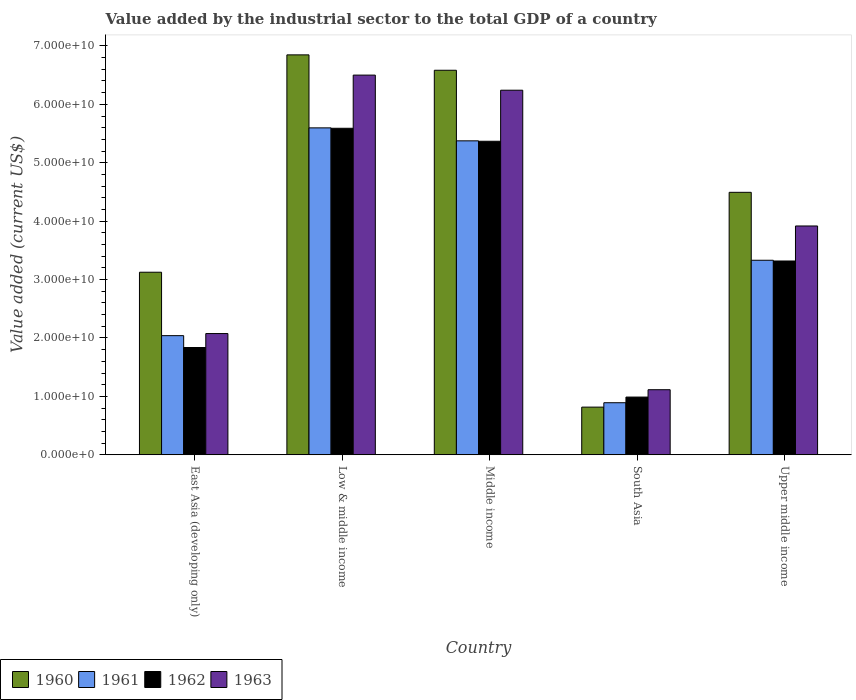Are the number of bars on each tick of the X-axis equal?
Provide a short and direct response. Yes. How many bars are there on the 1st tick from the left?
Your response must be concise. 4. How many bars are there on the 2nd tick from the right?
Give a very brief answer. 4. What is the label of the 1st group of bars from the left?
Keep it short and to the point. East Asia (developing only). What is the value added by the industrial sector to the total GDP in 1960 in South Asia?
Provide a short and direct response. 8.16e+09. Across all countries, what is the maximum value added by the industrial sector to the total GDP in 1963?
Keep it short and to the point. 6.50e+1. Across all countries, what is the minimum value added by the industrial sector to the total GDP in 1963?
Offer a terse response. 1.11e+1. What is the total value added by the industrial sector to the total GDP in 1963 in the graph?
Your answer should be very brief. 1.98e+11. What is the difference between the value added by the industrial sector to the total GDP in 1961 in Low & middle income and that in Middle income?
Make the answer very short. 2.22e+09. What is the difference between the value added by the industrial sector to the total GDP in 1962 in East Asia (developing only) and the value added by the industrial sector to the total GDP in 1961 in Middle income?
Keep it short and to the point. -3.54e+1. What is the average value added by the industrial sector to the total GDP in 1960 per country?
Your response must be concise. 4.37e+1. What is the difference between the value added by the industrial sector to the total GDP of/in 1960 and value added by the industrial sector to the total GDP of/in 1962 in East Asia (developing only)?
Make the answer very short. 1.29e+1. In how many countries, is the value added by the industrial sector to the total GDP in 1962 greater than 48000000000 US$?
Provide a succinct answer. 2. What is the ratio of the value added by the industrial sector to the total GDP in 1962 in East Asia (developing only) to that in Upper middle income?
Your answer should be compact. 0.55. Is the value added by the industrial sector to the total GDP in 1962 in Low & middle income less than that in South Asia?
Ensure brevity in your answer.  No. Is the difference between the value added by the industrial sector to the total GDP in 1960 in Middle income and Upper middle income greater than the difference between the value added by the industrial sector to the total GDP in 1962 in Middle income and Upper middle income?
Your answer should be compact. Yes. What is the difference between the highest and the second highest value added by the industrial sector to the total GDP in 1961?
Offer a very short reply. -2.04e+1. What is the difference between the highest and the lowest value added by the industrial sector to the total GDP in 1961?
Offer a terse response. 4.71e+1. Is the sum of the value added by the industrial sector to the total GDP in 1960 in East Asia (developing only) and Low & middle income greater than the maximum value added by the industrial sector to the total GDP in 1961 across all countries?
Your answer should be compact. Yes. Is it the case that in every country, the sum of the value added by the industrial sector to the total GDP in 1960 and value added by the industrial sector to the total GDP in 1962 is greater than the sum of value added by the industrial sector to the total GDP in 1963 and value added by the industrial sector to the total GDP in 1961?
Keep it short and to the point. No. What does the 3rd bar from the right in Upper middle income represents?
Keep it short and to the point. 1961. How many bars are there?
Provide a short and direct response. 20. How many countries are there in the graph?
Provide a short and direct response. 5. What is the difference between two consecutive major ticks on the Y-axis?
Keep it short and to the point. 1.00e+1. Where does the legend appear in the graph?
Your response must be concise. Bottom left. How many legend labels are there?
Provide a short and direct response. 4. How are the legend labels stacked?
Offer a very short reply. Horizontal. What is the title of the graph?
Your answer should be very brief. Value added by the industrial sector to the total GDP of a country. Does "1994" appear as one of the legend labels in the graph?
Provide a succinct answer. No. What is the label or title of the X-axis?
Provide a succinct answer. Country. What is the label or title of the Y-axis?
Your answer should be compact. Value added (current US$). What is the Value added (current US$) of 1960 in East Asia (developing only)?
Keep it short and to the point. 3.13e+1. What is the Value added (current US$) in 1961 in East Asia (developing only)?
Give a very brief answer. 2.04e+1. What is the Value added (current US$) of 1962 in East Asia (developing only)?
Provide a succinct answer. 1.84e+1. What is the Value added (current US$) in 1963 in East Asia (developing only)?
Ensure brevity in your answer.  2.08e+1. What is the Value added (current US$) in 1960 in Low & middle income?
Offer a terse response. 6.85e+1. What is the Value added (current US$) in 1961 in Low & middle income?
Your answer should be very brief. 5.60e+1. What is the Value added (current US$) of 1962 in Low & middle income?
Keep it short and to the point. 5.59e+1. What is the Value added (current US$) of 1963 in Low & middle income?
Offer a very short reply. 6.50e+1. What is the Value added (current US$) in 1960 in Middle income?
Your response must be concise. 6.58e+1. What is the Value added (current US$) of 1961 in Middle income?
Offer a very short reply. 5.37e+1. What is the Value added (current US$) of 1962 in Middle income?
Make the answer very short. 5.37e+1. What is the Value added (current US$) of 1963 in Middle income?
Offer a very short reply. 6.24e+1. What is the Value added (current US$) of 1960 in South Asia?
Give a very brief answer. 8.16e+09. What is the Value added (current US$) of 1961 in South Asia?
Keep it short and to the point. 8.91e+09. What is the Value added (current US$) in 1962 in South Asia?
Keep it short and to the point. 9.88e+09. What is the Value added (current US$) of 1963 in South Asia?
Keep it short and to the point. 1.11e+1. What is the Value added (current US$) of 1960 in Upper middle income?
Make the answer very short. 4.49e+1. What is the Value added (current US$) in 1961 in Upper middle income?
Provide a short and direct response. 3.33e+1. What is the Value added (current US$) in 1962 in Upper middle income?
Offer a very short reply. 3.32e+1. What is the Value added (current US$) of 1963 in Upper middle income?
Keep it short and to the point. 3.92e+1. Across all countries, what is the maximum Value added (current US$) in 1960?
Your answer should be very brief. 6.85e+1. Across all countries, what is the maximum Value added (current US$) of 1961?
Ensure brevity in your answer.  5.60e+1. Across all countries, what is the maximum Value added (current US$) of 1962?
Give a very brief answer. 5.59e+1. Across all countries, what is the maximum Value added (current US$) of 1963?
Provide a succinct answer. 6.50e+1. Across all countries, what is the minimum Value added (current US$) of 1960?
Offer a very short reply. 8.16e+09. Across all countries, what is the minimum Value added (current US$) of 1961?
Ensure brevity in your answer.  8.91e+09. Across all countries, what is the minimum Value added (current US$) of 1962?
Offer a very short reply. 9.88e+09. Across all countries, what is the minimum Value added (current US$) in 1963?
Your answer should be compact. 1.11e+1. What is the total Value added (current US$) in 1960 in the graph?
Your answer should be compact. 2.19e+11. What is the total Value added (current US$) in 1961 in the graph?
Provide a short and direct response. 1.72e+11. What is the total Value added (current US$) of 1962 in the graph?
Offer a terse response. 1.71e+11. What is the total Value added (current US$) of 1963 in the graph?
Make the answer very short. 1.98e+11. What is the difference between the Value added (current US$) of 1960 in East Asia (developing only) and that in Low & middle income?
Your answer should be compact. -3.72e+1. What is the difference between the Value added (current US$) in 1961 in East Asia (developing only) and that in Low & middle income?
Your answer should be compact. -3.56e+1. What is the difference between the Value added (current US$) of 1962 in East Asia (developing only) and that in Low & middle income?
Make the answer very short. -3.75e+1. What is the difference between the Value added (current US$) of 1963 in East Asia (developing only) and that in Low & middle income?
Offer a very short reply. -4.42e+1. What is the difference between the Value added (current US$) in 1960 in East Asia (developing only) and that in Middle income?
Keep it short and to the point. -3.46e+1. What is the difference between the Value added (current US$) of 1961 in East Asia (developing only) and that in Middle income?
Provide a succinct answer. -3.33e+1. What is the difference between the Value added (current US$) in 1962 in East Asia (developing only) and that in Middle income?
Make the answer very short. -3.53e+1. What is the difference between the Value added (current US$) of 1963 in East Asia (developing only) and that in Middle income?
Provide a short and direct response. -4.17e+1. What is the difference between the Value added (current US$) of 1960 in East Asia (developing only) and that in South Asia?
Provide a short and direct response. 2.31e+1. What is the difference between the Value added (current US$) of 1961 in East Asia (developing only) and that in South Asia?
Your answer should be compact. 1.15e+1. What is the difference between the Value added (current US$) of 1962 in East Asia (developing only) and that in South Asia?
Provide a succinct answer. 8.48e+09. What is the difference between the Value added (current US$) of 1963 in East Asia (developing only) and that in South Asia?
Keep it short and to the point. 9.61e+09. What is the difference between the Value added (current US$) of 1960 in East Asia (developing only) and that in Upper middle income?
Make the answer very short. -1.37e+1. What is the difference between the Value added (current US$) of 1961 in East Asia (developing only) and that in Upper middle income?
Your answer should be compact. -1.29e+1. What is the difference between the Value added (current US$) in 1962 in East Asia (developing only) and that in Upper middle income?
Provide a short and direct response. -1.48e+1. What is the difference between the Value added (current US$) in 1963 in East Asia (developing only) and that in Upper middle income?
Offer a very short reply. -1.84e+1. What is the difference between the Value added (current US$) of 1960 in Low & middle income and that in Middle income?
Offer a terse response. 2.63e+09. What is the difference between the Value added (current US$) of 1961 in Low & middle income and that in Middle income?
Your answer should be very brief. 2.22e+09. What is the difference between the Value added (current US$) of 1962 in Low & middle income and that in Middle income?
Give a very brief answer. 2.22e+09. What is the difference between the Value added (current US$) in 1963 in Low & middle income and that in Middle income?
Your answer should be compact. 2.59e+09. What is the difference between the Value added (current US$) of 1960 in Low & middle income and that in South Asia?
Your answer should be very brief. 6.03e+1. What is the difference between the Value added (current US$) in 1961 in Low & middle income and that in South Asia?
Give a very brief answer. 4.71e+1. What is the difference between the Value added (current US$) in 1962 in Low & middle income and that in South Asia?
Offer a terse response. 4.60e+1. What is the difference between the Value added (current US$) of 1963 in Low & middle income and that in South Asia?
Provide a succinct answer. 5.39e+1. What is the difference between the Value added (current US$) in 1960 in Low & middle income and that in Upper middle income?
Keep it short and to the point. 2.35e+1. What is the difference between the Value added (current US$) of 1961 in Low & middle income and that in Upper middle income?
Offer a terse response. 2.27e+1. What is the difference between the Value added (current US$) of 1962 in Low & middle income and that in Upper middle income?
Your answer should be very brief. 2.27e+1. What is the difference between the Value added (current US$) of 1963 in Low & middle income and that in Upper middle income?
Offer a very short reply. 2.58e+1. What is the difference between the Value added (current US$) of 1960 in Middle income and that in South Asia?
Your response must be concise. 5.77e+1. What is the difference between the Value added (current US$) of 1961 in Middle income and that in South Asia?
Provide a short and direct response. 4.48e+1. What is the difference between the Value added (current US$) of 1962 in Middle income and that in South Asia?
Ensure brevity in your answer.  4.38e+1. What is the difference between the Value added (current US$) of 1963 in Middle income and that in South Asia?
Make the answer very short. 5.13e+1. What is the difference between the Value added (current US$) in 1960 in Middle income and that in Upper middle income?
Ensure brevity in your answer.  2.09e+1. What is the difference between the Value added (current US$) in 1961 in Middle income and that in Upper middle income?
Give a very brief answer. 2.04e+1. What is the difference between the Value added (current US$) in 1962 in Middle income and that in Upper middle income?
Keep it short and to the point. 2.05e+1. What is the difference between the Value added (current US$) in 1963 in Middle income and that in Upper middle income?
Keep it short and to the point. 2.32e+1. What is the difference between the Value added (current US$) in 1960 in South Asia and that in Upper middle income?
Ensure brevity in your answer.  -3.68e+1. What is the difference between the Value added (current US$) of 1961 in South Asia and that in Upper middle income?
Your response must be concise. -2.44e+1. What is the difference between the Value added (current US$) of 1962 in South Asia and that in Upper middle income?
Provide a short and direct response. -2.33e+1. What is the difference between the Value added (current US$) in 1963 in South Asia and that in Upper middle income?
Your answer should be very brief. -2.80e+1. What is the difference between the Value added (current US$) in 1960 in East Asia (developing only) and the Value added (current US$) in 1961 in Low & middle income?
Make the answer very short. -2.47e+1. What is the difference between the Value added (current US$) in 1960 in East Asia (developing only) and the Value added (current US$) in 1962 in Low & middle income?
Your response must be concise. -2.46e+1. What is the difference between the Value added (current US$) of 1960 in East Asia (developing only) and the Value added (current US$) of 1963 in Low & middle income?
Keep it short and to the point. -3.37e+1. What is the difference between the Value added (current US$) in 1961 in East Asia (developing only) and the Value added (current US$) in 1962 in Low & middle income?
Provide a short and direct response. -3.55e+1. What is the difference between the Value added (current US$) in 1961 in East Asia (developing only) and the Value added (current US$) in 1963 in Low & middle income?
Your answer should be compact. -4.46e+1. What is the difference between the Value added (current US$) of 1962 in East Asia (developing only) and the Value added (current US$) of 1963 in Low & middle income?
Keep it short and to the point. -4.66e+1. What is the difference between the Value added (current US$) in 1960 in East Asia (developing only) and the Value added (current US$) in 1961 in Middle income?
Offer a very short reply. -2.25e+1. What is the difference between the Value added (current US$) of 1960 in East Asia (developing only) and the Value added (current US$) of 1962 in Middle income?
Your response must be concise. -2.24e+1. What is the difference between the Value added (current US$) in 1960 in East Asia (developing only) and the Value added (current US$) in 1963 in Middle income?
Keep it short and to the point. -3.12e+1. What is the difference between the Value added (current US$) of 1961 in East Asia (developing only) and the Value added (current US$) of 1962 in Middle income?
Keep it short and to the point. -3.33e+1. What is the difference between the Value added (current US$) in 1961 in East Asia (developing only) and the Value added (current US$) in 1963 in Middle income?
Your response must be concise. -4.20e+1. What is the difference between the Value added (current US$) of 1962 in East Asia (developing only) and the Value added (current US$) of 1963 in Middle income?
Your answer should be compact. -4.41e+1. What is the difference between the Value added (current US$) of 1960 in East Asia (developing only) and the Value added (current US$) of 1961 in South Asia?
Keep it short and to the point. 2.23e+1. What is the difference between the Value added (current US$) in 1960 in East Asia (developing only) and the Value added (current US$) in 1962 in South Asia?
Provide a succinct answer. 2.14e+1. What is the difference between the Value added (current US$) in 1960 in East Asia (developing only) and the Value added (current US$) in 1963 in South Asia?
Your answer should be very brief. 2.01e+1. What is the difference between the Value added (current US$) in 1961 in East Asia (developing only) and the Value added (current US$) in 1962 in South Asia?
Provide a succinct answer. 1.05e+1. What is the difference between the Value added (current US$) in 1961 in East Asia (developing only) and the Value added (current US$) in 1963 in South Asia?
Your response must be concise. 9.26e+09. What is the difference between the Value added (current US$) in 1962 in East Asia (developing only) and the Value added (current US$) in 1963 in South Asia?
Make the answer very short. 7.22e+09. What is the difference between the Value added (current US$) of 1960 in East Asia (developing only) and the Value added (current US$) of 1961 in Upper middle income?
Provide a short and direct response. -2.05e+09. What is the difference between the Value added (current US$) in 1960 in East Asia (developing only) and the Value added (current US$) in 1962 in Upper middle income?
Offer a terse response. -1.92e+09. What is the difference between the Value added (current US$) in 1960 in East Asia (developing only) and the Value added (current US$) in 1963 in Upper middle income?
Offer a very short reply. -7.92e+09. What is the difference between the Value added (current US$) in 1961 in East Asia (developing only) and the Value added (current US$) in 1962 in Upper middle income?
Provide a succinct answer. -1.28e+1. What is the difference between the Value added (current US$) in 1961 in East Asia (developing only) and the Value added (current US$) in 1963 in Upper middle income?
Keep it short and to the point. -1.88e+1. What is the difference between the Value added (current US$) of 1962 in East Asia (developing only) and the Value added (current US$) of 1963 in Upper middle income?
Your response must be concise. -2.08e+1. What is the difference between the Value added (current US$) in 1960 in Low & middle income and the Value added (current US$) in 1961 in Middle income?
Give a very brief answer. 1.47e+1. What is the difference between the Value added (current US$) in 1960 in Low & middle income and the Value added (current US$) in 1962 in Middle income?
Your answer should be very brief. 1.48e+1. What is the difference between the Value added (current US$) in 1960 in Low & middle income and the Value added (current US$) in 1963 in Middle income?
Offer a terse response. 6.05e+09. What is the difference between the Value added (current US$) of 1961 in Low & middle income and the Value added (current US$) of 1962 in Middle income?
Offer a terse response. 2.29e+09. What is the difference between the Value added (current US$) of 1961 in Low & middle income and the Value added (current US$) of 1963 in Middle income?
Your response must be concise. -6.45e+09. What is the difference between the Value added (current US$) in 1962 in Low & middle income and the Value added (current US$) in 1963 in Middle income?
Give a very brief answer. -6.52e+09. What is the difference between the Value added (current US$) of 1960 in Low & middle income and the Value added (current US$) of 1961 in South Asia?
Give a very brief answer. 5.96e+1. What is the difference between the Value added (current US$) in 1960 in Low & middle income and the Value added (current US$) in 1962 in South Asia?
Provide a succinct answer. 5.86e+1. What is the difference between the Value added (current US$) of 1960 in Low & middle income and the Value added (current US$) of 1963 in South Asia?
Keep it short and to the point. 5.73e+1. What is the difference between the Value added (current US$) in 1961 in Low & middle income and the Value added (current US$) in 1962 in South Asia?
Offer a terse response. 4.61e+1. What is the difference between the Value added (current US$) in 1961 in Low & middle income and the Value added (current US$) in 1963 in South Asia?
Your answer should be compact. 4.48e+1. What is the difference between the Value added (current US$) of 1962 in Low & middle income and the Value added (current US$) of 1963 in South Asia?
Give a very brief answer. 4.48e+1. What is the difference between the Value added (current US$) of 1960 in Low & middle income and the Value added (current US$) of 1961 in Upper middle income?
Provide a short and direct response. 3.52e+1. What is the difference between the Value added (current US$) of 1960 in Low & middle income and the Value added (current US$) of 1962 in Upper middle income?
Make the answer very short. 3.53e+1. What is the difference between the Value added (current US$) in 1960 in Low & middle income and the Value added (current US$) in 1963 in Upper middle income?
Keep it short and to the point. 2.93e+1. What is the difference between the Value added (current US$) in 1961 in Low & middle income and the Value added (current US$) in 1962 in Upper middle income?
Offer a terse response. 2.28e+1. What is the difference between the Value added (current US$) in 1961 in Low & middle income and the Value added (current US$) in 1963 in Upper middle income?
Offer a terse response. 1.68e+1. What is the difference between the Value added (current US$) in 1962 in Low & middle income and the Value added (current US$) in 1963 in Upper middle income?
Make the answer very short. 1.67e+1. What is the difference between the Value added (current US$) of 1960 in Middle income and the Value added (current US$) of 1961 in South Asia?
Keep it short and to the point. 5.69e+1. What is the difference between the Value added (current US$) of 1960 in Middle income and the Value added (current US$) of 1962 in South Asia?
Your answer should be very brief. 5.59e+1. What is the difference between the Value added (current US$) in 1960 in Middle income and the Value added (current US$) in 1963 in South Asia?
Your answer should be compact. 5.47e+1. What is the difference between the Value added (current US$) in 1961 in Middle income and the Value added (current US$) in 1962 in South Asia?
Your answer should be very brief. 4.39e+1. What is the difference between the Value added (current US$) in 1961 in Middle income and the Value added (current US$) in 1963 in South Asia?
Keep it short and to the point. 4.26e+1. What is the difference between the Value added (current US$) in 1962 in Middle income and the Value added (current US$) in 1963 in South Asia?
Offer a very short reply. 4.25e+1. What is the difference between the Value added (current US$) of 1960 in Middle income and the Value added (current US$) of 1961 in Upper middle income?
Provide a short and direct response. 3.25e+1. What is the difference between the Value added (current US$) of 1960 in Middle income and the Value added (current US$) of 1962 in Upper middle income?
Provide a succinct answer. 3.27e+1. What is the difference between the Value added (current US$) of 1960 in Middle income and the Value added (current US$) of 1963 in Upper middle income?
Your response must be concise. 2.67e+1. What is the difference between the Value added (current US$) in 1961 in Middle income and the Value added (current US$) in 1962 in Upper middle income?
Keep it short and to the point. 2.06e+1. What is the difference between the Value added (current US$) in 1961 in Middle income and the Value added (current US$) in 1963 in Upper middle income?
Offer a terse response. 1.46e+1. What is the difference between the Value added (current US$) in 1962 in Middle income and the Value added (current US$) in 1963 in Upper middle income?
Make the answer very short. 1.45e+1. What is the difference between the Value added (current US$) in 1960 in South Asia and the Value added (current US$) in 1961 in Upper middle income?
Provide a short and direct response. -2.51e+1. What is the difference between the Value added (current US$) of 1960 in South Asia and the Value added (current US$) of 1962 in Upper middle income?
Offer a very short reply. -2.50e+1. What is the difference between the Value added (current US$) of 1960 in South Asia and the Value added (current US$) of 1963 in Upper middle income?
Provide a short and direct response. -3.10e+1. What is the difference between the Value added (current US$) in 1961 in South Asia and the Value added (current US$) in 1962 in Upper middle income?
Offer a very short reply. -2.43e+1. What is the difference between the Value added (current US$) of 1961 in South Asia and the Value added (current US$) of 1963 in Upper middle income?
Provide a short and direct response. -3.03e+1. What is the difference between the Value added (current US$) in 1962 in South Asia and the Value added (current US$) in 1963 in Upper middle income?
Your answer should be compact. -2.93e+1. What is the average Value added (current US$) of 1960 per country?
Make the answer very short. 4.37e+1. What is the average Value added (current US$) of 1961 per country?
Give a very brief answer. 3.45e+1. What is the average Value added (current US$) of 1962 per country?
Provide a short and direct response. 3.42e+1. What is the average Value added (current US$) in 1963 per country?
Provide a short and direct response. 3.97e+1. What is the difference between the Value added (current US$) in 1960 and Value added (current US$) in 1961 in East Asia (developing only)?
Your answer should be very brief. 1.09e+1. What is the difference between the Value added (current US$) in 1960 and Value added (current US$) in 1962 in East Asia (developing only)?
Ensure brevity in your answer.  1.29e+1. What is the difference between the Value added (current US$) of 1960 and Value added (current US$) of 1963 in East Asia (developing only)?
Your answer should be very brief. 1.05e+1. What is the difference between the Value added (current US$) in 1961 and Value added (current US$) in 1962 in East Asia (developing only)?
Your answer should be very brief. 2.03e+09. What is the difference between the Value added (current US$) in 1961 and Value added (current US$) in 1963 in East Asia (developing only)?
Give a very brief answer. -3.57e+08. What is the difference between the Value added (current US$) in 1962 and Value added (current US$) in 1963 in East Asia (developing only)?
Offer a very short reply. -2.39e+09. What is the difference between the Value added (current US$) of 1960 and Value added (current US$) of 1961 in Low & middle income?
Your response must be concise. 1.25e+1. What is the difference between the Value added (current US$) in 1960 and Value added (current US$) in 1962 in Low & middle income?
Make the answer very short. 1.26e+1. What is the difference between the Value added (current US$) in 1960 and Value added (current US$) in 1963 in Low & middle income?
Offer a terse response. 3.46e+09. What is the difference between the Value added (current US$) of 1961 and Value added (current US$) of 1962 in Low & middle income?
Offer a terse response. 7.11e+07. What is the difference between the Value added (current US$) in 1961 and Value added (current US$) in 1963 in Low & middle income?
Keep it short and to the point. -9.03e+09. What is the difference between the Value added (current US$) of 1962 and Value added (current US$) of 1963 in Low & middle income?
Offer a terse response. -9.10e+09. What is the difference between the Value added (current US$) in 1960 and Value added (current US$) in 1961 in Middle income?
Ensure brevity in your answer.  1.21e+1. What is the difference between the Value added (current US$) in 1960 and Value added (current US$) in 1962 in Middle income?
Give a very brief answer. 1.22e+1. What is the difference between the Value added (current US$) in 1960 and Value added (current US$) in 1963 in Middle income?
Offer a terse response. 3.41e+09. What is the difference between the Value added (current US$) in 1961 and Value added (current US$) in 1962 in Middle income?
Offer a terse response. 7.12e+07. What is the difference between the Value added (current US$) in 1961 and Value added (current US$) in 1963 in Middle income?
Provide a succinct answer. -8.67e+09. What is the difference between the Value added (current US$) of 1962 and Value added (current US$) of 1963 in Middle income?
Your answer should be compact. -8.74e+09. What is the difference between the Value added (current US$) in 1960 and Value added (current US$) in 1961 in South Asia?
Give a very brief answer. -7.53e+08. What is the difference between the Value added (current US$) of 1960 and Value added (current US$) of 1962 in South Asia?
Offer a terse response. -1.72e+09. What is the difference between the Value added (current US$) in 1960 and Value added (current US$) in 1963 in South Asia?
Your answer should be compact. -2.98e+09. What is the difference between the Value added (current US$) in 1961 and Value added (current US$) in 1962 in South Asia?
Your answer should be very brief. -9.68e+08. What is the difference between the Value added (current US$) in 1961 and Value added (current US$) in 1963 in South Asia?
Give a very brief answer. -2.23e+09. What is the difference between the Value added (current US$) in 1962 and Value added (current US$) in 1963 in South Asia?
Give a very brief answer. -1.26e+09. What is the difference between the Value added (current US$) in 1960 and Value added (current US$) in 1961 in Upper middle income?
Provide a succinct answer. 1.16e+1. What is the difference between the Value added (current US$) in 1960 and Value added (current US$) in 1962 in Upper middle income?
Your response must be concise. 1.18e+1. What is the difference between the Value added (current US$) of 1960 and Value added (current US$) of 1963 in Upper middle income?
Provide a succinct answer. 5.76e+09. What is the difference between the Value added (current US$) in 1961 and Value added (current US$) in 1962 in Upper middle income?
Make the answer very short. 1.26e+08. What is the difference between the Value added (current US$) of 1961 and Value added (current US$) of 1963 in Upper middle income?
Offer a very short reply. -5.87e+09. What is the difference between the Value added (current US$) in 1962 and Value added (current US$) in 1963 in Upper middle income?
Provide a succinct answer. -5.99e+09. What is the ratio of the Value added (current US$) in 1960 in East Asia (developing only) to that in Low & middle income?
Make the answer very short. 0.46. What is the ratio of the Value added (current US$) in 1961 in East Asia (developing only) to that in Low & middle income?
Make the answer very short. 0.36. What is the ratio of the Value added (current US$) in 1962 in East Asia (developing only) to that in Low & middle income?
Make the answer very short. 0.33. What is the ratio of the Value added (current US$) in 1963 in East Asia (developing only) to that in Low & middle income?
Make the answer very short. 0.32. What is the ratio of the Value added (current US$) in 1960 in East Asia (developing only) to that in Middle income?
Give a very brief answer. 0.47. What is the ratio of the Value added (current US$) of 1961 in East Asia (developing only) to that in Middle income?
Offer a very short reply. 0.38. What is the ratio of the Value added (current US$) in 1962 in East Asia (developing only) to that in Middle income?
Your answer should be compact. 0.34. What is the ratio of the Value added (current US$) in 1963 in East Asia (developing only) to that in Middle income?
Offer a very short reply. 0.33. What is the ratio of the Value added (current US$) of 1960 in East Asia (developing only) to that in South Asia?
Offer a terse response. 3.83. What is the ratio of the Value added (current US$) in 1961 in East Asia (developing only) to that in South Asia?
Your answer should be very brief. 2.29. What is the ratio of the Value added (current US$) of 1962 in East Asia (developing only) to that in South Asia?
Ensure brevity in your answer.  1.86. What is the ratio of the Value added (current US$) in 1963 in East Asia (developing only) to that in South Asia?
Ensure brevity in your answer.  1.86. What is the ratio of the Value added (current US$) in 1960 in East Asia (developing only) to that in Upper middle income?
Give a very brief answer. 0.7. What is the ratio of the Value added (current US$) of 1961 in East Asia (developing only) to that in Upper middle income?
Provide a short and direct response. 0.61. What is the ratio of the Value added (current US$) in 1962 in East Asia (developing only) to that in Upper middle income?
Ensure brevity in your answer.  0.55. What is the ratio of the Value added (current US$) of 1963 in East Asia (developing only) to that in Upper middle income?
Keep it short and to the point. 0.53. What is the ratio of the Value added (current US$) of 1961 in Low & middle income to that in Middle income?
Give a very brief answer. 1.04. What is the ratio of the Value added (current US$) of 1962 in Low & middle income to that in Middle income?
Ensure brevity in your answer.  1.04. What is the ratio of the Value added (current US$) in 1963 in Low & middle income to that in Middle income?
Offer a very short reply. 1.04. What is the ratio of the Value added (current US$) in 1960 in Low & middle income to that in South Asia?
Your response must be concise. 8.39. What is the ratio of the Value added (current US$) of 1961 in Low & middle income to that in South Asia?
Your answer should be compact. 6.28. What is the ratio of the Value added (current US$) of 1962 in Low & middle income to that in South Asia?
Give a very brief answer. 5.66. What is the ratio of the Value added (current US$) in 1963 in Low & middle income to that in South Asia?
Keep it short and to the point. 5.83. What is the ratio of the Value added (current US$) of 1960 in Low & middle income to that in Upper middle income?
Give a very brief answer. 1.52. What is the ratio of the Value added (current US$) of 1961 in Low & middle income to that in Upper middle income?
Your answer should be very brief. 1.68. What is the ratio of the Value added (current US$) of 1962 in Low & middle income to that in Upper middle income?
Your response must be concise. 1.68. What is the ratio of the Value added (current US$) in 1963 in Low & middle income to that in Upper middle income?
Offer a terse response. 1.66. What is the ratio of the Value added (current US$) of 1960 in Middle income to that in South Asia?
Provide a succinct answer. 8.07. What is the ratio of the Value added (current US$) in 1961 in Middle income to that in South Asia?
Your answer should be very brief. 6.03. What is the ratio of the Value added (current US$) of 1962 in Middle income to that in South Asia?
Offer a terse response. 5.43. What is the ratio of the Value added (current US$) of 1963 in Middle income to that in South Asia?
Offer a terse response. 5.6. What is the ratio of the Value added (current US$) of 1960 in Middle income to that in Upper middle income?
Your response must be concise. 1.47. What is the ratio of the Value added (current US$) of 1961 in Middle income to that in Upper middle income?
Your response must be concise. 1.61. What is the ratio of the Value added (current US$) in 1962 in Middle income to that in Upper middle income?
Provide a succinct answer. 1.62. What is the ratio of the Value added (current US$) of 1963 in Middle income to that in Upper middle income?
Your response must be concise. 1.59. What is the ratio of the Value added (current US$) in 1960 in South Asia to that in Upper middle income?
Provide a succinct answer. 0.18. What is the ratio of the Value added (current US$) of 1961 in South Asia to that in Upper middle income?
Make the answer very short. 0.27. What is the ratio of the Value added (current US$) in 1962 in South Asia to that in Upper middle income?
Keep it short and to the point. 0.3. What is the ratio of the Value added (current US$) in 1963 in South Asia to that in Upper middle income?
Your answer should be compact. 0.28. What is the difference between the highest and the second highest Value added (current US$) in 1960?
Offer a very short reply. 2.63e+09. What is the difference between the highest and the second highest Value added (current US$) of 1961?
Your response must be concise. 2.22e+09. What is the difference between the highest and the second highest Value added (current US$) in 1962?
Offer a terse response. 2.22e+09. What is the difference between the highest and the second highest Value added (current US$) in 1963?
Your response must be concise. 2.59e+09. What is the difference between the highest and the lowest Value added (current US$) in 1960?
Your response must be concise. 6.03e+1. What is the difference between the highest and the lowest Value added (current US$) of 1961?
Your answer should be compact. 4.71e+1. What is the difference between the highest and the lowest Value added (current US$) of 1962?
Make the answer very short. 4.60e+1. What is the difference between the highest and the lowest Value added (current US$) of 1963?
Make the answer very short. 5.39e+1. 